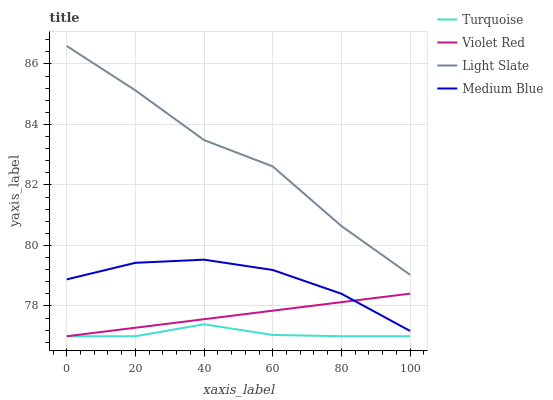Does Medium Blue have the minimum area under the curve?
Answer yes or no. No. Does Medium Blue have the maximum area under the curve?
Answer yes or no. No. Is Turquoise the smoothest?
Answer yes or no. No. Is Turquoise the roughest?
Answer yes or no. No. Does Medium Blue have the lowest value?
Answer yes or no. No. Does Medium Blue have the highest value?
Answer yes or no. No. Is Turquoise less than Medium Blue?
Answer yes or no. Yes. Is Light Slate greater than Violet Red?
Answer yes or no. Yes. Does Turquoise intersect Medium Blue?
Answer yes or no. No. 